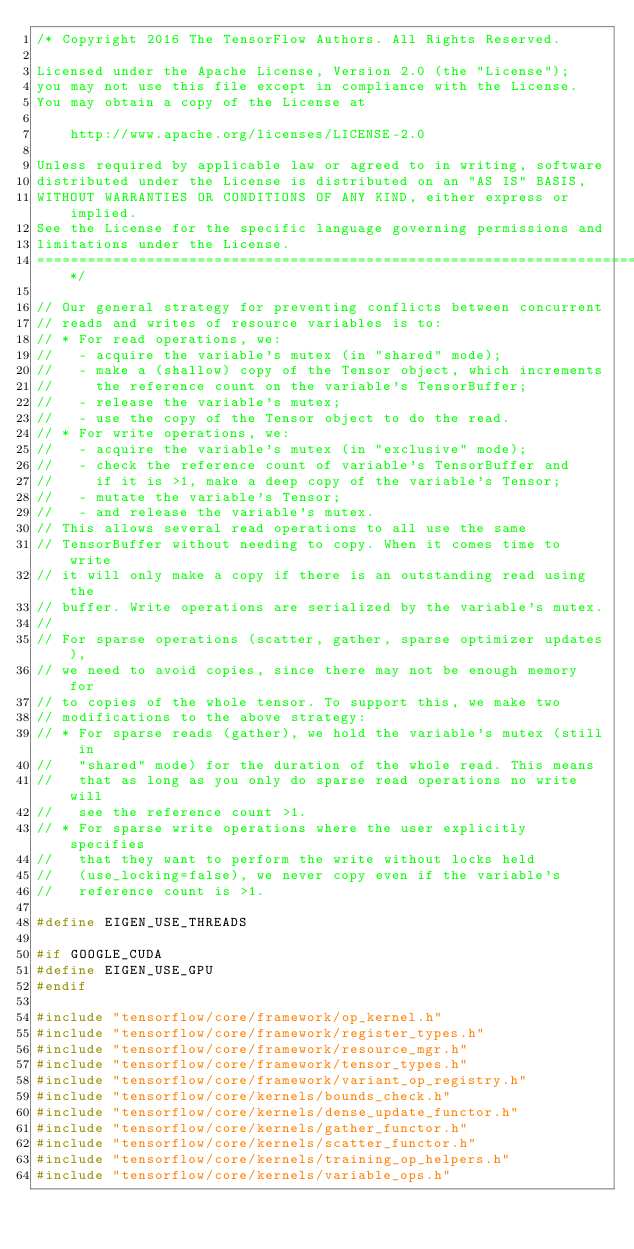Convert code to text. <code><loc_0><loc_0><loc_500><loc_500><_C++_>/* Copyright 2016 The TensorFlow Authors. All Rights Reserved.

Licensed under the Apache License, Version 2.0 (the "License");
you may not use this file except in compliance with the License.
You may obtain a copy of the License at

    http://www.apache.org/licenses/LICENSE-2.0

Unless required by applicable law or agreed to in writing, software
distributed under the License is distributed on an "AS IS" BASIS,
WITHOUT WARRANTIES OR CONDITIONS OF ANY KIND, either express or implied.
See the License for the specific language governing permissions and
limitations under the License.
==============================================================================*/

// Our general strategy for preventing conflicts between concurrent
// reads and writes of resource variables is to:
// * For read operations, we:
//   - acquire the variable's mutex (in "shared" mode);
//   - make a (shallow) copy of the Tensor object, which increments
//     the reference count on the variable's TensorBuffer;
//   - release the variable's mutex;
//   - use the copy of the Tensor object to do the read.
// * For write operations, we:
//   - acquire the variable's mutex (in "exclusive" mode);
//   - check the reference count of variable's TensorBuffer and
//     if it is >1, make a deep copy of the variable's Tensor;
//   - mutate the variable's Tensor;
//   - and release the variable's mutex.
// This allows several read operations to all use the same
// TensorBuffer without needing to copy. When it comes time to write
// it will only make a copy if there is an outstanding read using the
// buffer. Write operations are serialized by the variable's mutex.
//
// For sparse operations (scatter, gather, sparse optimizer updates),
// we need to avoid copies, since there may not be enough memory for
// to copies of the whole tensor. To support this, we make two
// modifications to the above strategy:
// * For sparse reads (gather), we hold the variable's mutex (still in
//   "shared" mode) for the duration of the whole read. This means
//   that as long as you only do sparse read operations no write will
//   see the reference count >1.
// * For sparse write operations where the user explicitly specifies
//   that they want to perform the write without locks held
//   (use_locking=false), we never copy even if the variable's
//   reference count is >1.

#define EIGEN_USE_THREADS

#if GOOGLE_CUDA
#define EIGEN_USE_GPU
#endif

#include "tensorflow/core/framework/op_kernel.h"
#include "tensorflow/core/framework/register_types.h"
#include "tensorflow/core/framework/resource_mgr.h"
#include "tensorflow/core/framework/tensor_types.h"
#include "tensorflow/core/framework/variant_op_registry.h"
#include "tensorflow/core/kernels/bounds_check.h"
#include "tensorflow/core/kernels/dense_update_functor.h"
#include "tensorflow/core/kernels/gather_functor.h"
#include "tensorflow/core/kernels/scatter_functor.h"
#include "tensorflow/core/kernels/training_op_helpers.h"
#include "tensorflow/core/kernels/variable_ops.h"</code> 